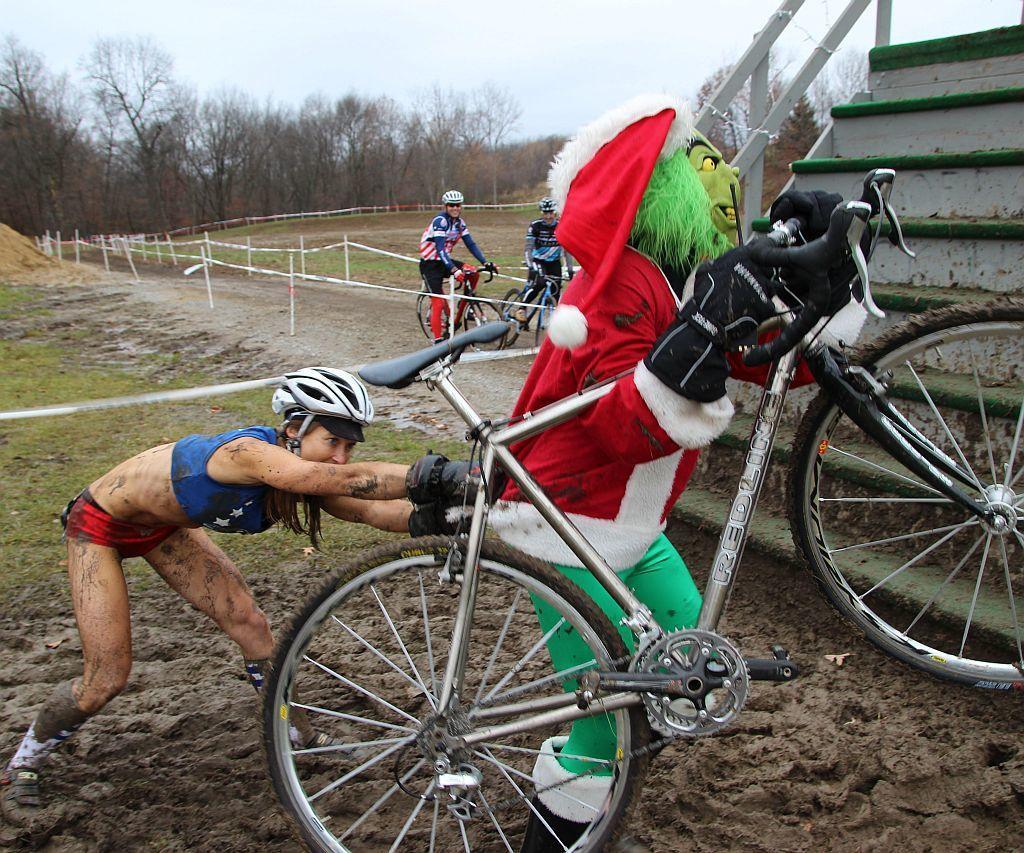In one or two sentences, can you explain what this image depicts? There are four people and bicycles are present at the bottom of this image. We can see a fence and trees in the background and the sky at the top of this image. The stairs are on the right side of this image. 